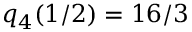<formula> <loc_0><loc_0><loc_500><loc_500>q _ { 4 } ( 1 / 2 ) = 1 6 / 3</formula> 